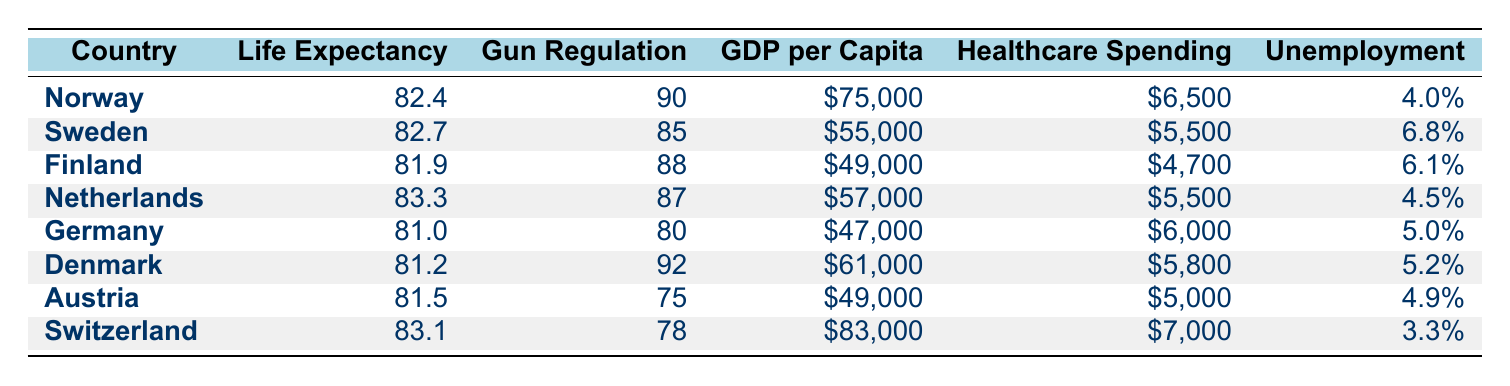What is the life expectancy in Switzerland? The table shows that Switzerland has a life expectancy of 83.1 years.
Answer: 83.1 Which country has the highest gun regulation score? According to the table, Denmark has the highest gun regulation score of 92.
Answer: Denmark What is the average GDP per capita for the countries listed? To find the average, sum the GDP per capita values: 75000 + 55000 + 49000 + 57000 + 47000 + 61000 + 49000 + 83000 =  395000. Then divide by the number of countries (8): 395000 / 8 = 49375.
Answer: 49375 Is it true that Sweden has a higher life expectancy than Germany? Yes, Sweden's life expectancy is 82.7 years, while Germany's is 81.0 years, confirming that Sweden has a higher life expectancy.
Answer: Yes Which country has the lowest unemployment rate among those listed? The table indicates that Switzerland has the lowest unemployment rate at 3.3%.
Answer: Switzerland What is the difference in life expectancy between Norway and Finland? Norway's life expectancy is 82.4 years and Finland's is 81.9 years. The difference is calculated as 82.4 - 81.9 = 0.5 years.
Answer: 0.5 Does Germany have a higher GDP per capita than Finland? Yes, Germany's GDP per capita is 47000, which is higher than Finland's 49000.
Answer: No Which country has both a high gun regulation score and high healthcare spending per capita? The table reveals that Norway has a gun regulation score of 90 and healthcare spending of 6500, making it a country with both high metrics.
Answer: Norway What is the relationship between gun regulation score and life expectancy for these countries? Looking at the table, countries with higher gun regulation scores, like Denmark (92) and Norway (90), tend to have higher life expectancies. This suggests a positive correlation.
Answer: Positive correlation 